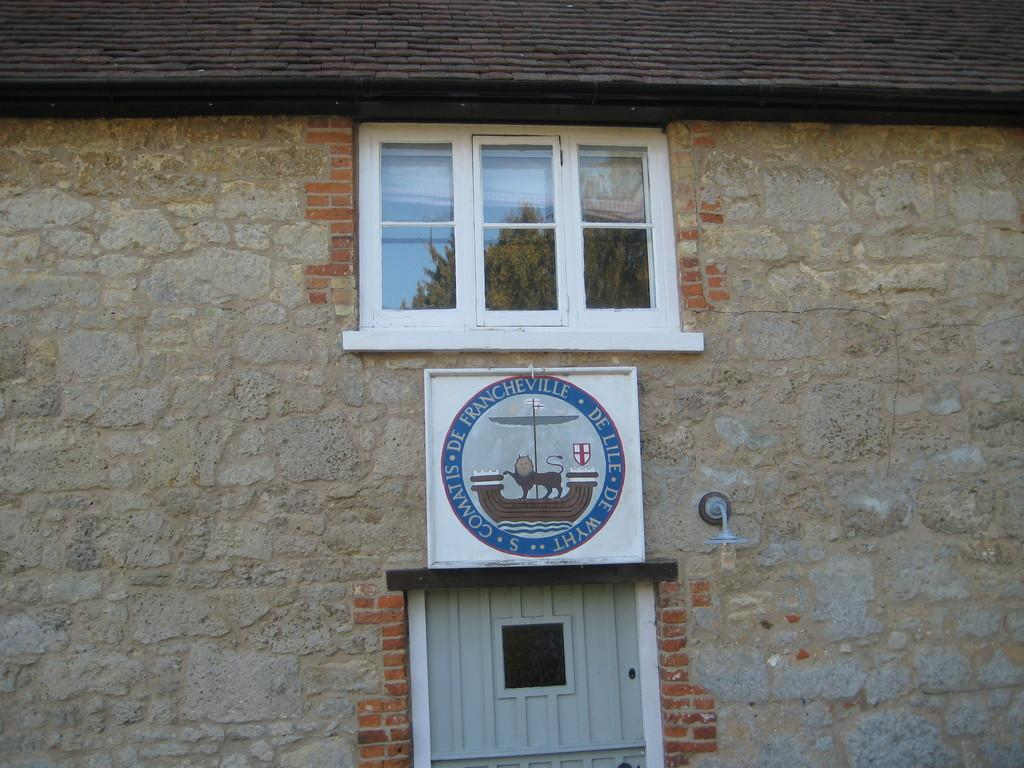What type of structure is visible in the image? There is a brick wall in the image. What architectural feature can be seen in the wall? There is a window in the image. Is there an entrance visible in the image? Yes, there is a door in the image. What object is attached to the wall in the image? There is a board in the image. What can be used to illuminate the area in the image? There is a light in the image. What type of toothpaste is being advertised on the board in the image? There is no toothpaste or advertisement present in the image; it only features a brick wall, window, door, board, and light. 